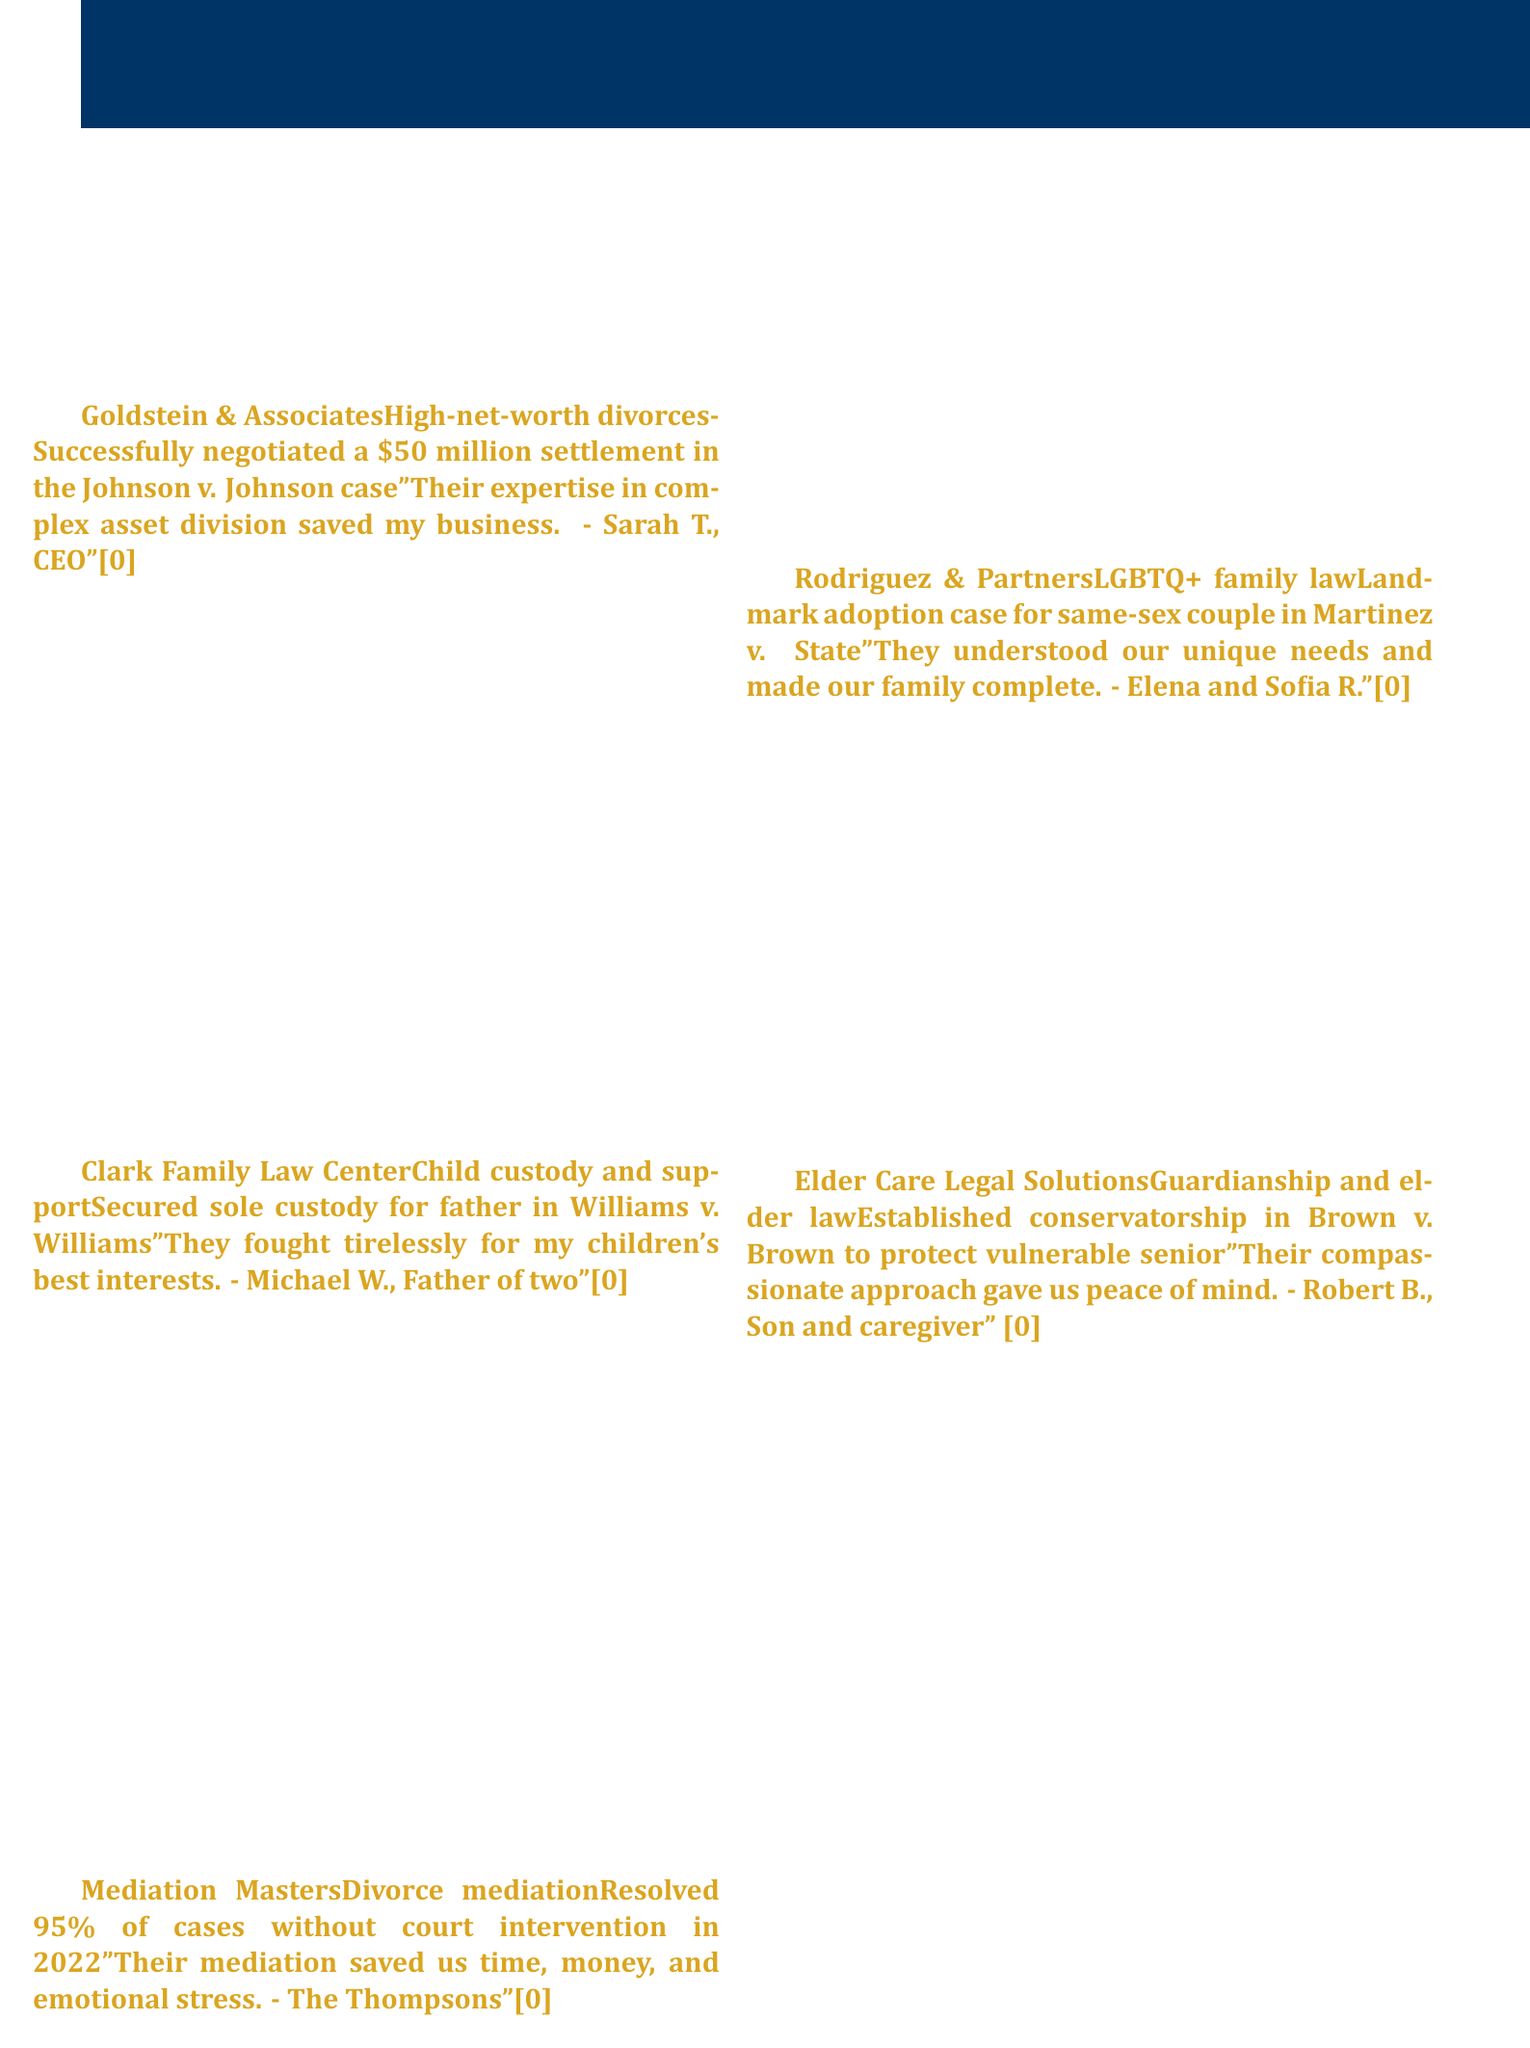What is the specialization of Goldstein & Associates? The specialization is explicitly stated in the document under each firm and for Goldstein & Associates, it is "High-net-worth divorces."
Answer: High-net-worth divorces What was the case history for Clark Family Law Center? The case history provides a specific example of the firm's work in family law, which is "Secured sole custody for father in Williams v. Williams."
Answer: Secured sole custody for father in Williams v. Williams How many cases did Mediation Masters resolve without court intervention in 2022? The document specifies the percentage of cases resolved without court intervention in a specific year, which is "95%."
Answer: 95% What did Elena and Sofia R. say in their testimonial? The testimonial quotes from clients reflect their experience and satisfaction, which mentions "They understood our unique needs and made our family complete."
Answer: They understood our unique needs and made our family complete Who is the contact person listed in the document? The document includes contact information where the name of the contact is provided, which is "James Harper, Esq."
Answer: James Harper, Esq What is the phone number provided for James Harper? The document clearly states the phone number associated with the contact person, which is "(555) 123-4567."
Answer: (555) 123-4567 Which firm specializes in LGBTQ+ family law? The document specifies the specialization of each firm, and for LGBTQ+ family law, it states "Rodriguez & Partners."
Answer: Rodriguez & Partners What was established in the case history for Elder Care Legal Solutions? The case history highlights a specific legal action taken, which is "Established conservatorship in Brown v. Brown to protect vulnerable senior."
Answer: Established conservatorship in Brown v. Brown to protect vulnerable senior 